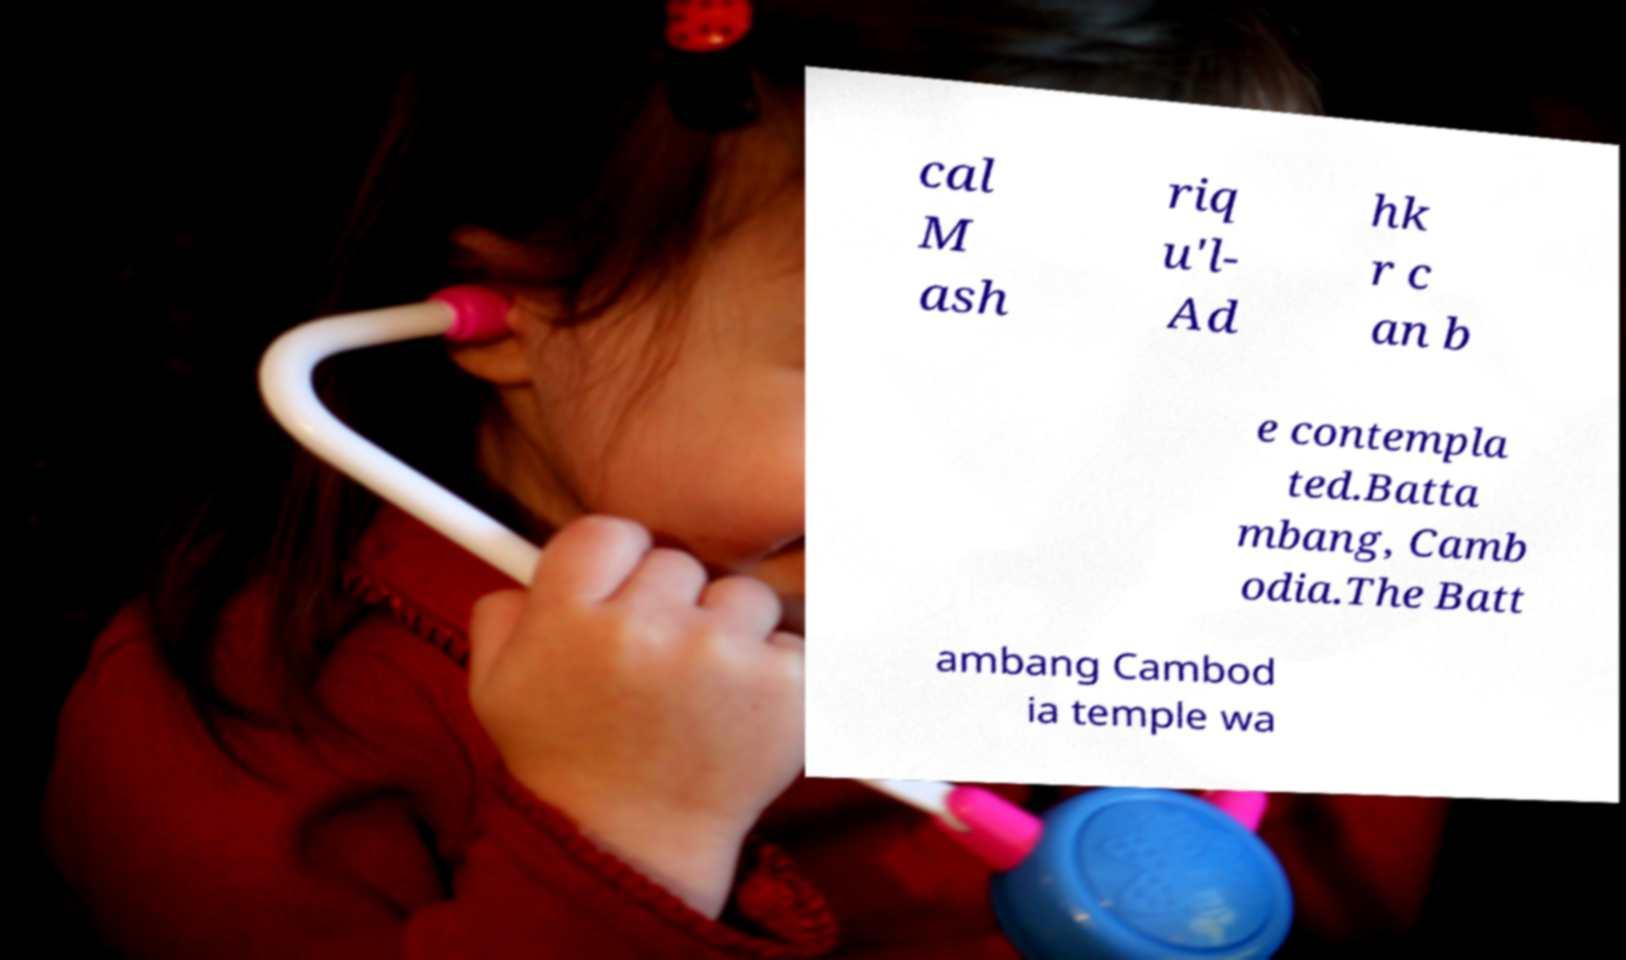There's text embedded in this image that I need extracted. Can you transcribe it verbatim? cal M ash riq u'l- Ad hk r c an b e contempla ted.Batta mbang, Camb odia.The Batt ambang Cambod ia temple wa 